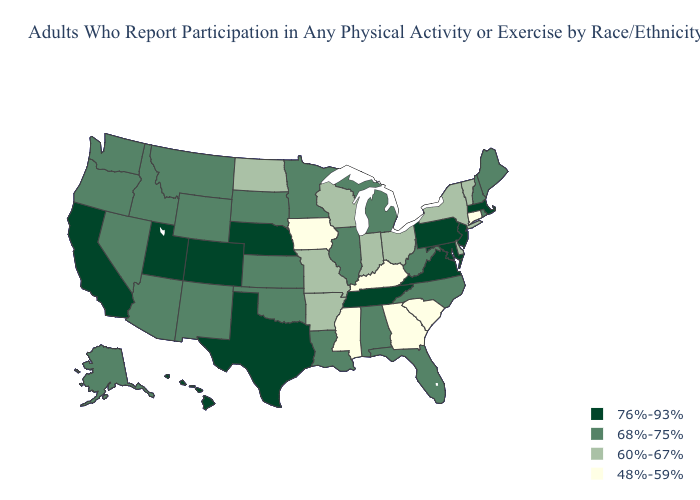What is the value of Michigan?
Give a very brief answer. 68%-75%. Name the states that have a value in the range 48%-59%?
Be succinct. Connecticut, Georgia, Iowa, Kentucky, Mississippi, South Carolina. Does South Carolina have the lowest value in the South?
Quick response, please. Yes. Among the states that border Wisconsin , which have the lowest value?
Give a very brief answer. Iowa. Which states have the lowest value in the West?
Keep it brief. Alaska, Arizona, Idaho, Montana, Nevada, New Mexico, Oregon, Washington, Wyoming. Does Ohio have the same value as Nebraska?
Quick response, please. No. Does Nebraska have a higher value than Illinois?
Short answer required. Yes. What is the highest value in the West ?
Give a very brief answer. 76%-93%. Among the states that border Illinois , which have the lowest value?
Keep it brief. Iowa, Kentucky. Does Florida have the lowest value in the USA?
Write a very short answer. No. What is the value of Montana?
Short answer required. 68%-75%. Does Wyoming have the highest value in the USA?
Answer briefly. No. Does South Carolina have the lowest value in the USA?
Give a very brief answer. Yes. What is the value of Colorado?
Be succinct. 76%-93%. What is the value of Mississippi?
Be succinct. 48%-59%. 